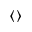<formula> <loc_0><loc_0><loc_500><loc_500>\langle \rangle</formula> 